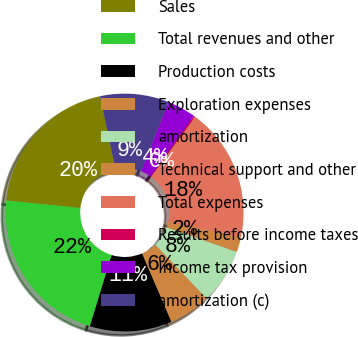Convert chart. <chart><loc_0><loc_0><loc_500><loc_500><pie_chart><fcel>Sales<fcel>Total revenues and other<fcel>Production costs<fcel>Exploration expenses<fcel>amortization<fcel>Technical support and other<fcel>Total expenses<fcel>Results before income taxes<fcel>Income tax provision<fcel>amortization (c)<nl><fcel>20.07%<fcel>21.9%<fcel>11.16%<fcel>5.68%<fcel>7.51%<fcel>2.03%<fcel>18.25%<fcel>0.21%<fcel>3.86%<fcel>9.33%<nl></chart> 